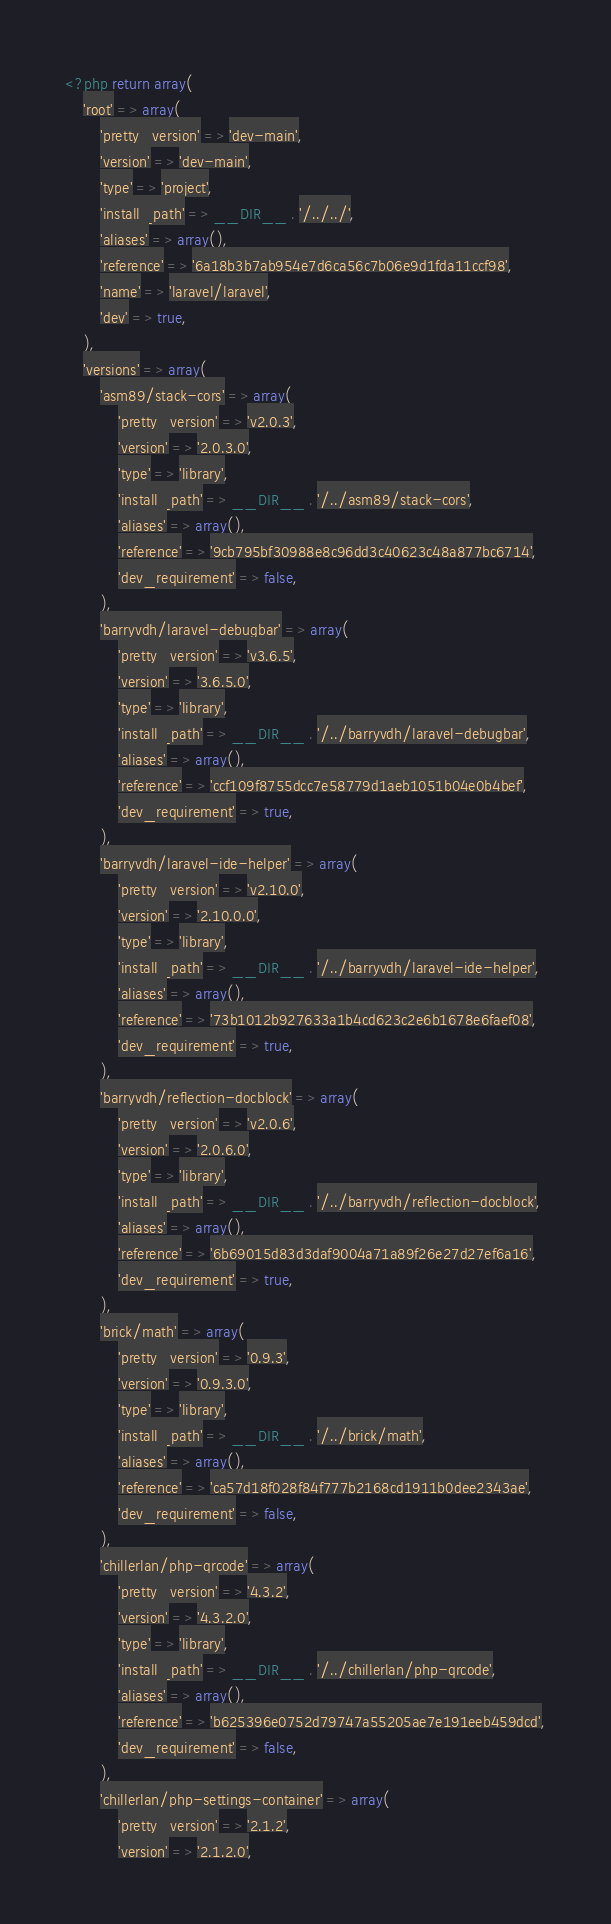<code> <loc_0><loc_0><loc_500><loc_500><_PHP_><?php return array(
    'root' => array(
        'pretty_version' => 'dev-main',
        'version' => 'dev-main',
        'type' => 'project',
        'install_path' => __DIR__ . '/../../',
        'aliases' => array(),
        'reference' => '6a18b3b7ab954e7d6ca56c7b06e9d1fda11ccf98',
        'name' => 'laravel/laravel',
        'dev' => true,
    ),
    'versions' => array(
        'asm89/stack-cors' => array(
            'pretty_version' => 'v2.0.3',
            'version' => '2.0.3.0',
            'type' => 'library',
            'install_path' => __DIR__ . '/../asm89/stack-cors',
            'aliases' => array(),
            'reference' => '9cb795bf30988e8c96dd3c40623c48a877bc6714',
            'dev_requirement' => false,
        ),
        'barryvdh/laravel-debugbar' => array(
            'pretty_version' => 'v3.6.5',
            'version' => '3.6.5.0',
            'type' => 'library',
            'install_path' => __DIR__ . '/../barryvdh/laravel-debugbar',
            'aliases' => array(),
            'reference' => 'ccf109f8755dcc7e58779d1aeb1051b04e0b4bef',
            'dev_requirement' => true,
        ),
        'barryvdh/laravel-ide-helper' => array(
            'pretty_version' => 'v2.10.0',
            'version' => '2.10.0.0',
            'type' => 'library',
            'install_path' => __DIR__ . '/../barryvdh/laravel-ide-helper',
            'aliases' => array(),
            'reference' => '73b1012b927633a1b4cd623c2e6b1678e6faef08',
            'dev_requirement' => true,
        ),
        'barryvdh/reflection-docblock' => array(
            'pretty_version' => 'v2.0.6',
            'version' => '2.0.6.0',
            'type' => 'library',
            'install_path' => __DIR__ . '/../barryvdh/reflection-docblock',
            'aliases' => array(),
            'reference' => '6b69015d83d3daf9004a71a89f26e27d27ef6a16',
            'dev_requirement' => true,
        ),
        'brick/math' => array(
            'pretty_version' => '0.9.3',
            'version' => '0.9.3.0',
            'type' => 'library',
            'install_path' => __DIR__ . '/../brick/math',
            'aliases' => array(),
            'reference' => 'ca57d18f028f84f777b2168cd1911b0dee2343ae',
            'dev_requirement' => false,
        ),
        'chillerlan/php-qrcode' => array(
            'pretty_version' => '4.3.2',
            'version' => '4.3.2.0',
            'type' => 'library',
            'install_path' => __DIR__ . '/../chillerlan/php-qrcode',
            'aliases' => array(),
            'reference' => 'b625396e0752d79747a55205ae7e191eeb459dcd',
            'dev_requirement' => false,
        ),
        'chillerlan/php-settings-container' => array(
            'pretty_version' => '2.1.2',
            'version' => '2.1.2.0',</code> 